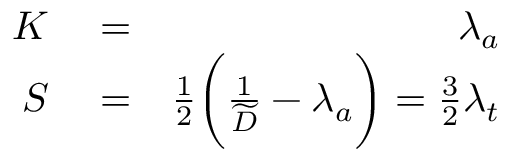Convert formula to latex. <formula><loc_0><loc_0><loc_500><loc_500>\begin{array} { r l r } { K } & = } & { \lambda _ { a } } \\ { S } & = } & { \frac { 1 } { 2 } \left ( \frac { 1 } { \widetilde { D } } - \lambda _ { a } \right ) = \frac { 3 } { 2 } \lambda _ { t } } \end{array}</formula> 